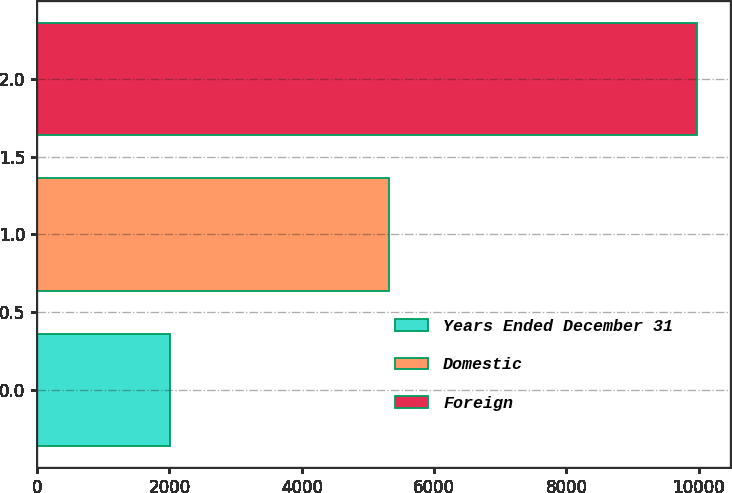Convert chart. <chart><loc_0><loc_0><loc_500><loc_500><bar_chart><fcel>Years Ended December 31<fcel>Domestic<fcel>Foreign<nl><fcel>2009<fcel>5318<fcel>9972<nl></chart> 